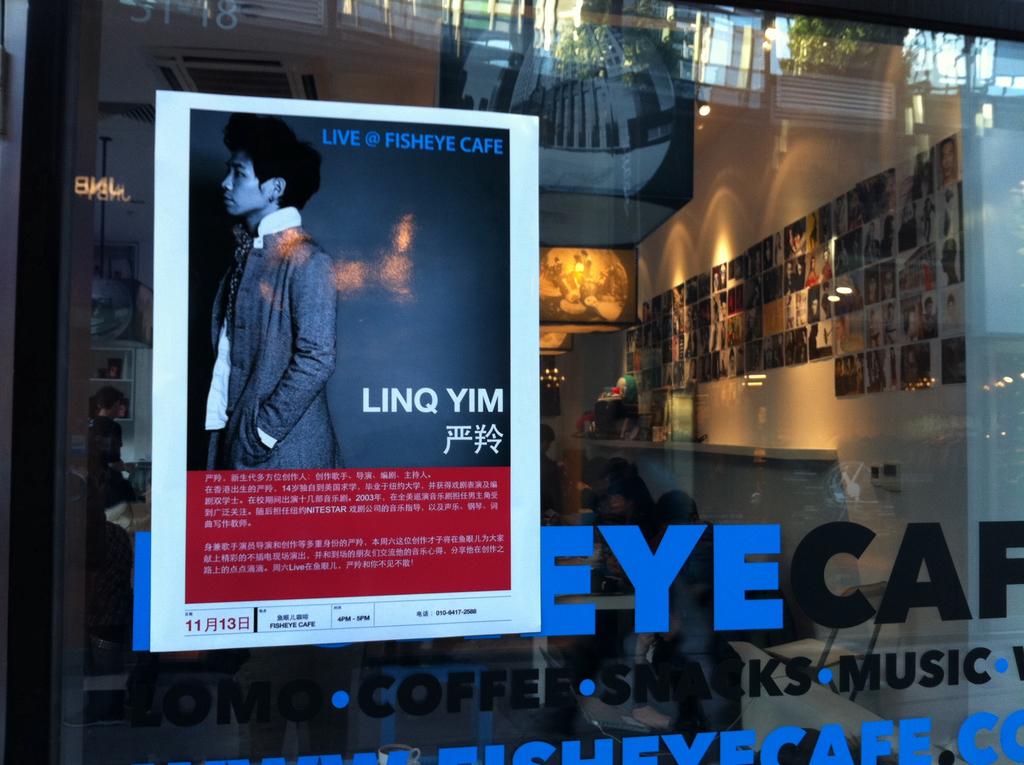At what establishment will this performer be live?
Provide a short and direct response. Fisheye cafe. What body part is written in blue?
Keep it short and to the point. Eye. 